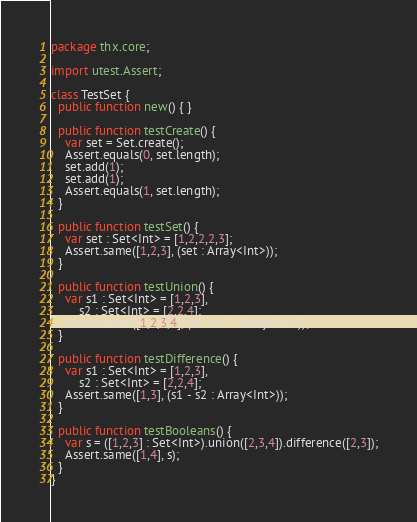Convert code to text. <code><loc_0><loc_0><loc_500><loc_500><_Haxe_>package thx.core;

import utest.Assert;

class TestSet {
  public function new() { }

  public function testCreate() {
    var set = Set.create();
    Assert.equals(0, set.length);
    set.add(1);
    set.add(1);
    Assert.equals(1, set.length);
  }

  public function testSet() {
    var set : Set<Int> = [1,2,2,2,3];
    Assert.same([1,2,3], (set : Array<Int>));
  }

  public function testUnion() {
    var s1 : Set<Int> = [1,2,3],
        s2 : Set<Int> = [2,2,4];
    Assert.same([1,2,3,4], (s1 + s2 : Array<Int>));
  }

  public function testDifference() {
    var s1 : Set<Int> = [1,2,3],
        s2 : Set<Int> = [2,2,4];
    Assert.same([1,3], (s1 - s2 : Array<Int>));
  }

  public function testBooleans() {
    var s = ([1,2,3] : Set<Int>).union([2,3,4]).difference([2,3]);
    Assert.same([1,4], s);
  }
}
</code> 